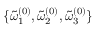<formula> <loc_0><loc_0><loc_500><loc_500>\{ { \tilde { \omega } _ { 1 } } ^ { ( 0 ) } , { \tilde { \omega } _ { 2 } } ^ { ( 0 ) } , { \tilde { \omega } _ { 3 } } ^ { ( 0 ) } \}</formula> 